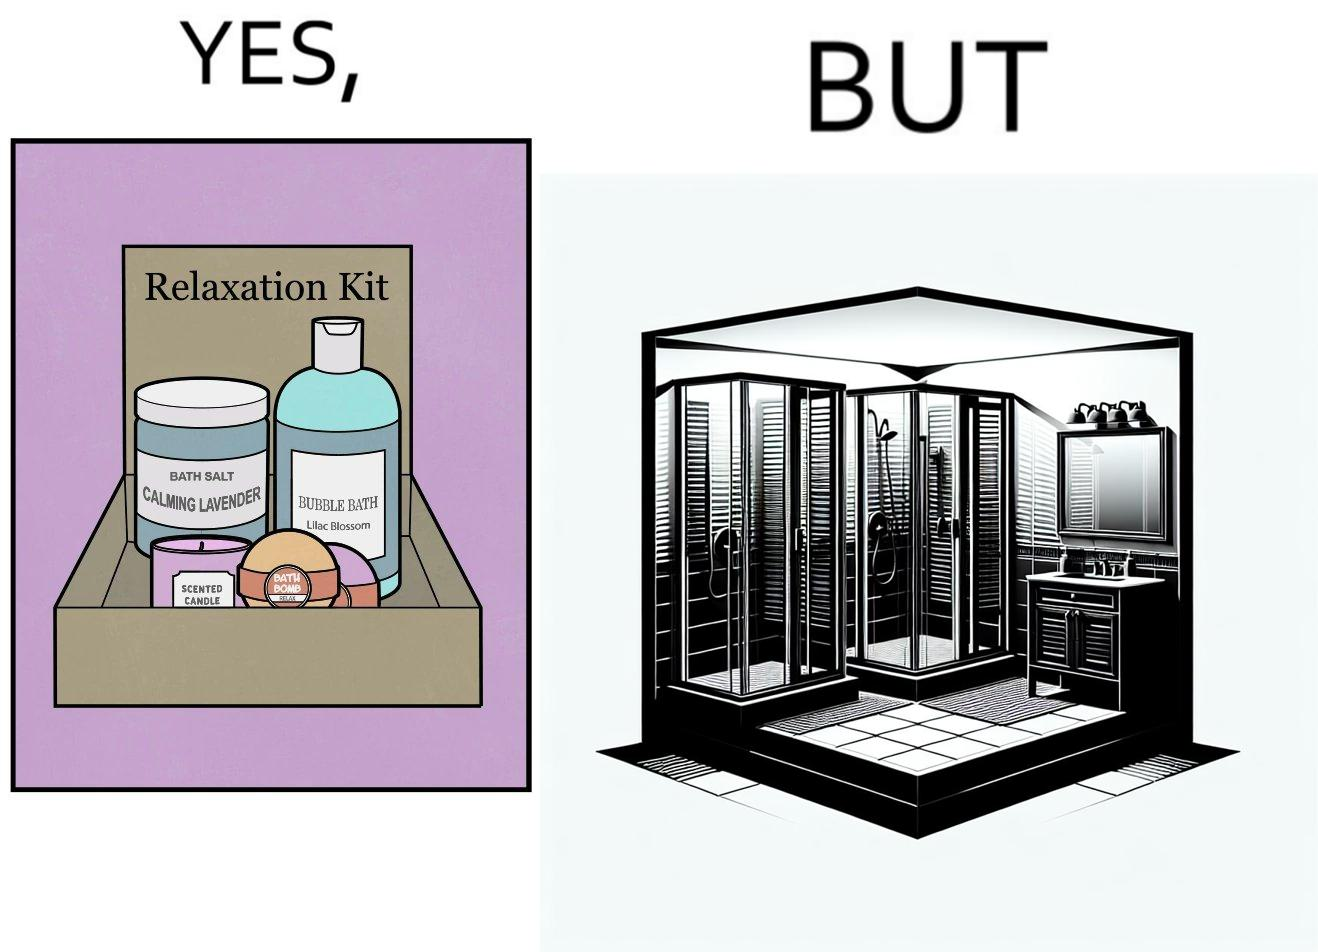Is this image satirical or non-satirical? Yes, this image is satirical. 